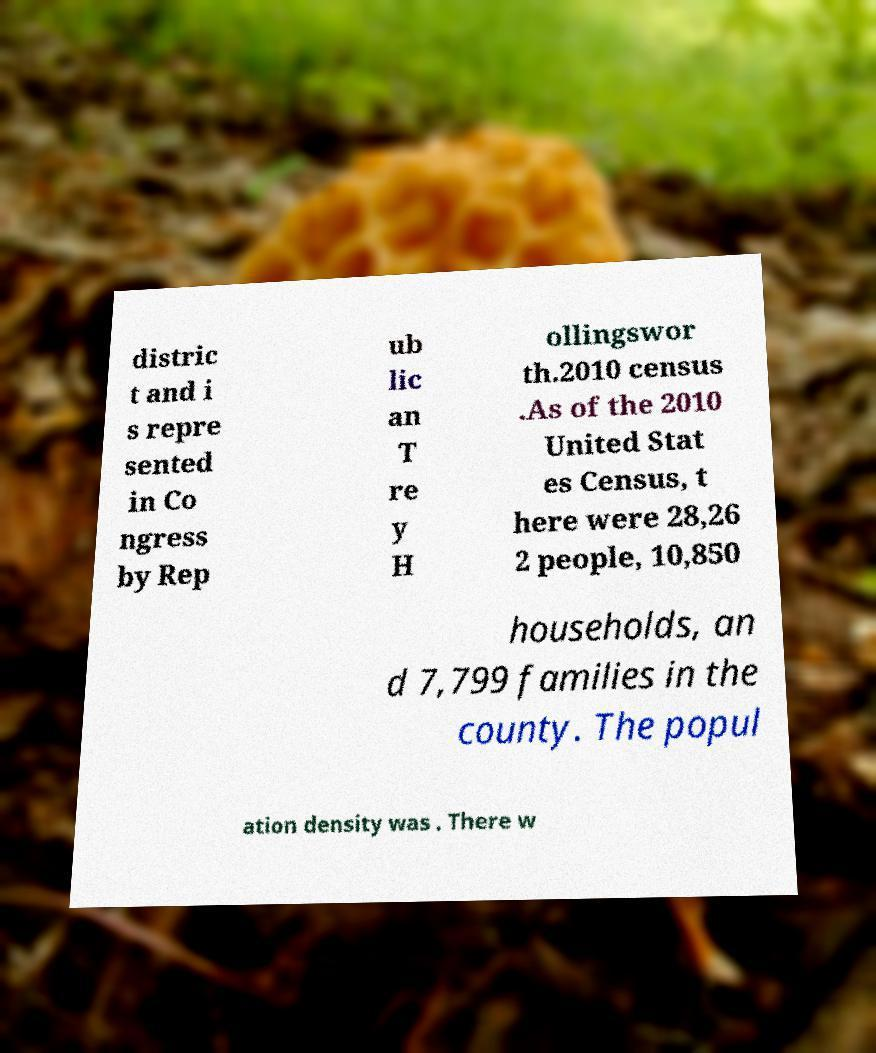Please identify and transcribe the text found in this image. distric t and i s repre sented in Co ngress by Rep ub lic an T re y H ollingswor th.2010 census .As of the 2010 United Stat es Census, t here were 28,26 2 people, 10,850 households, an d 7,799 families in the county. The popul ation density was . There w 